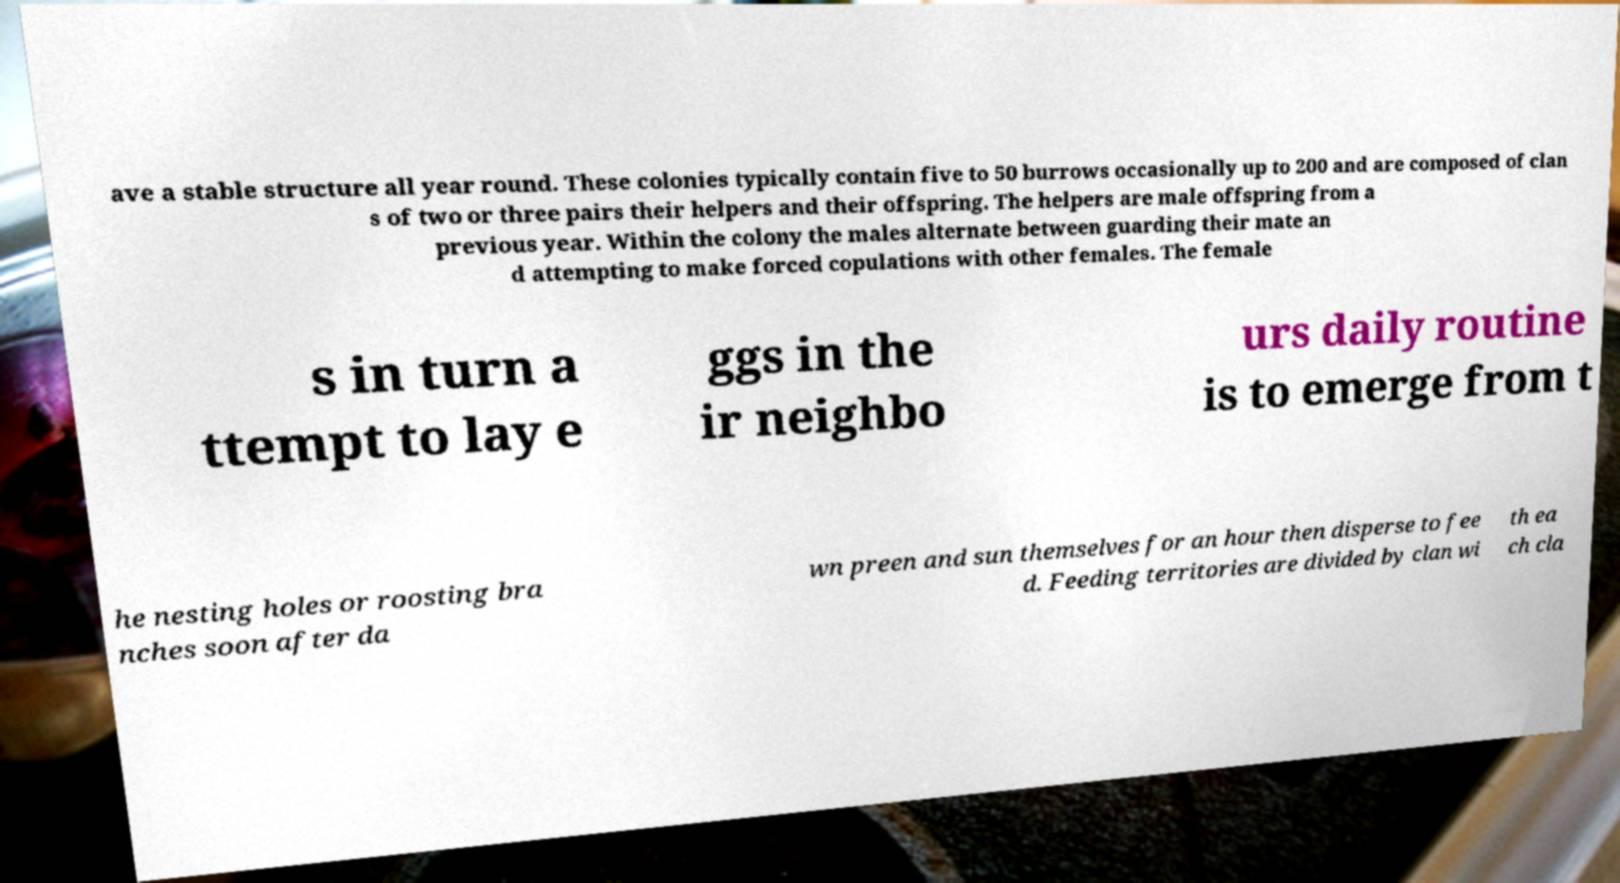Please read and relay the text visible in this image. What does it say? ave a stable structure all year round. These colonies typically contain five to 50 burrows occasionally up to 200 and are composed of clan s of two or three pairs their helpers and their offspring. The helpers are male offspring from a previous year. Within the colony the males alternate between guarding their mate an d attempting to make forced copulations with other females. The female s in turn a ttempt to lay e ggs in the ir neighbo urs daily routine is to emerge from t he nesting holes or roosting bra nches soon after da wn preen and sun themselves for an hour then disperse to fee d. Feeding territories are divided by clan wi th ea ch cla 